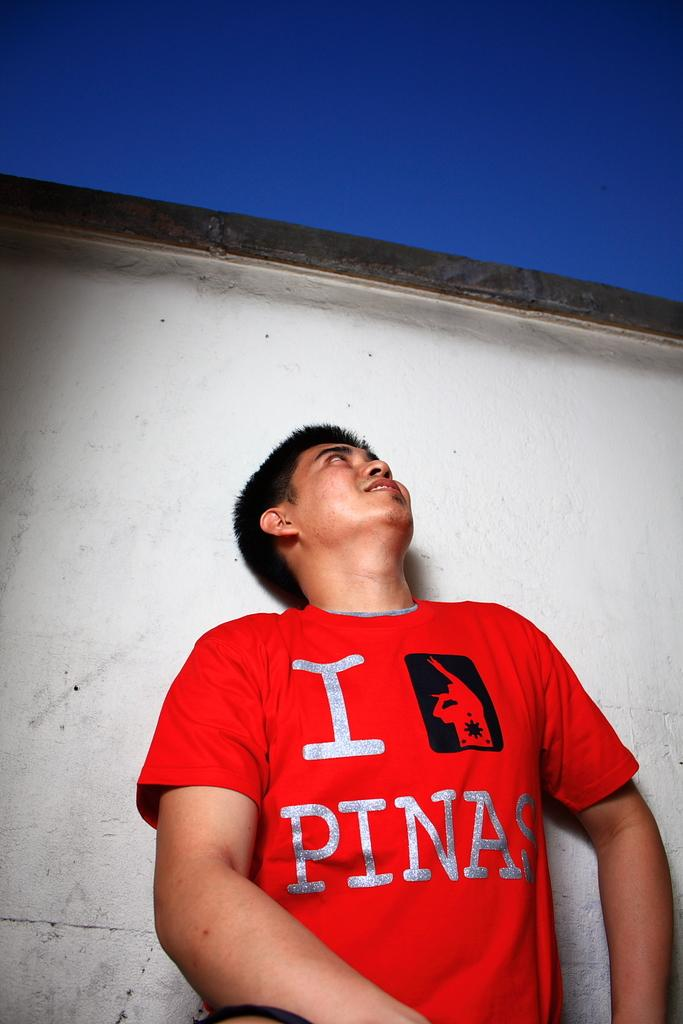<image>
Give a short and clear explanation of the subsequent image. guy looking upward wearing red tshirt with I PINAS on it 